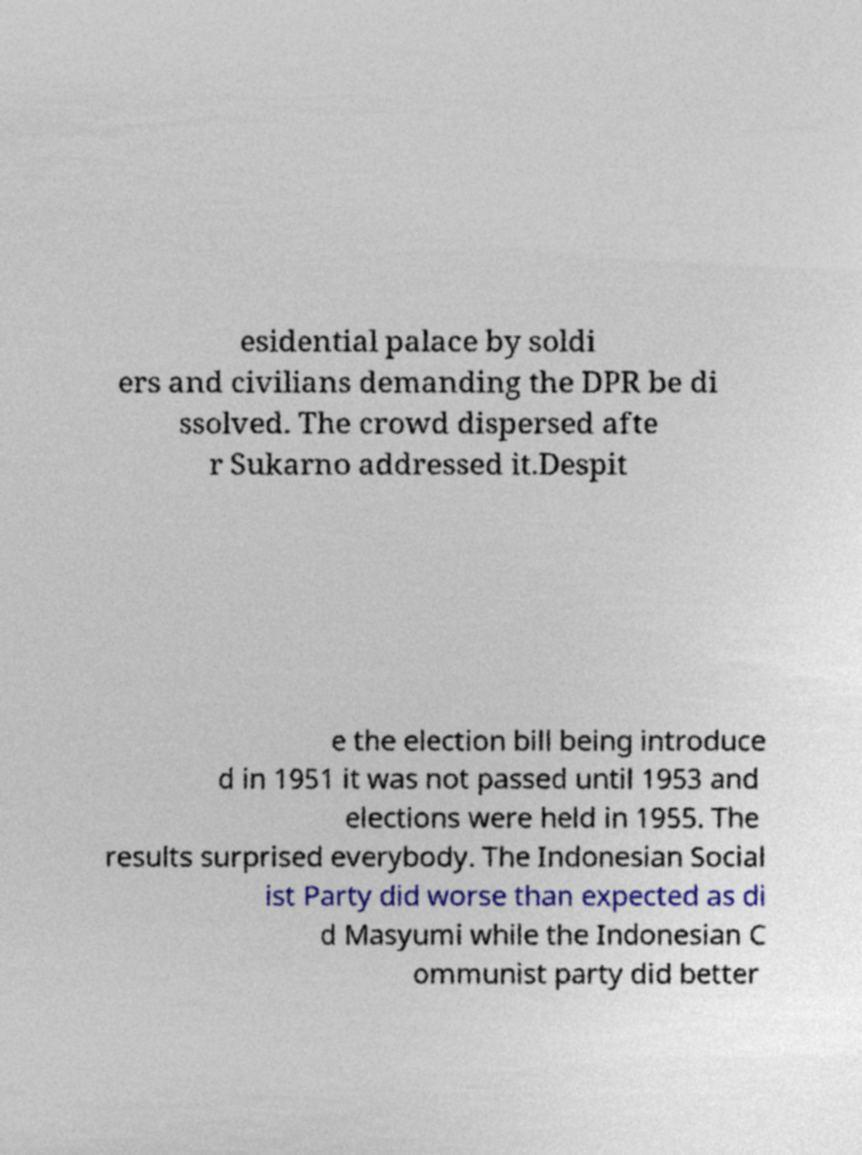Could you assist in decoding the text presented in this image and type it out clearly? esidential palace by soldi ers and civilians demanding the DPR be di ssolved. The crowd dispersed afte r Sukarno addressed it.Despit e the election bill being introduce d in 1951 it was not passed until 1953 and elections were held in 1955. The results surprised everybody. The Indonesian Social ist Party did worse than expected as di d Masyumi while the Indonesian C ommunist party did better 